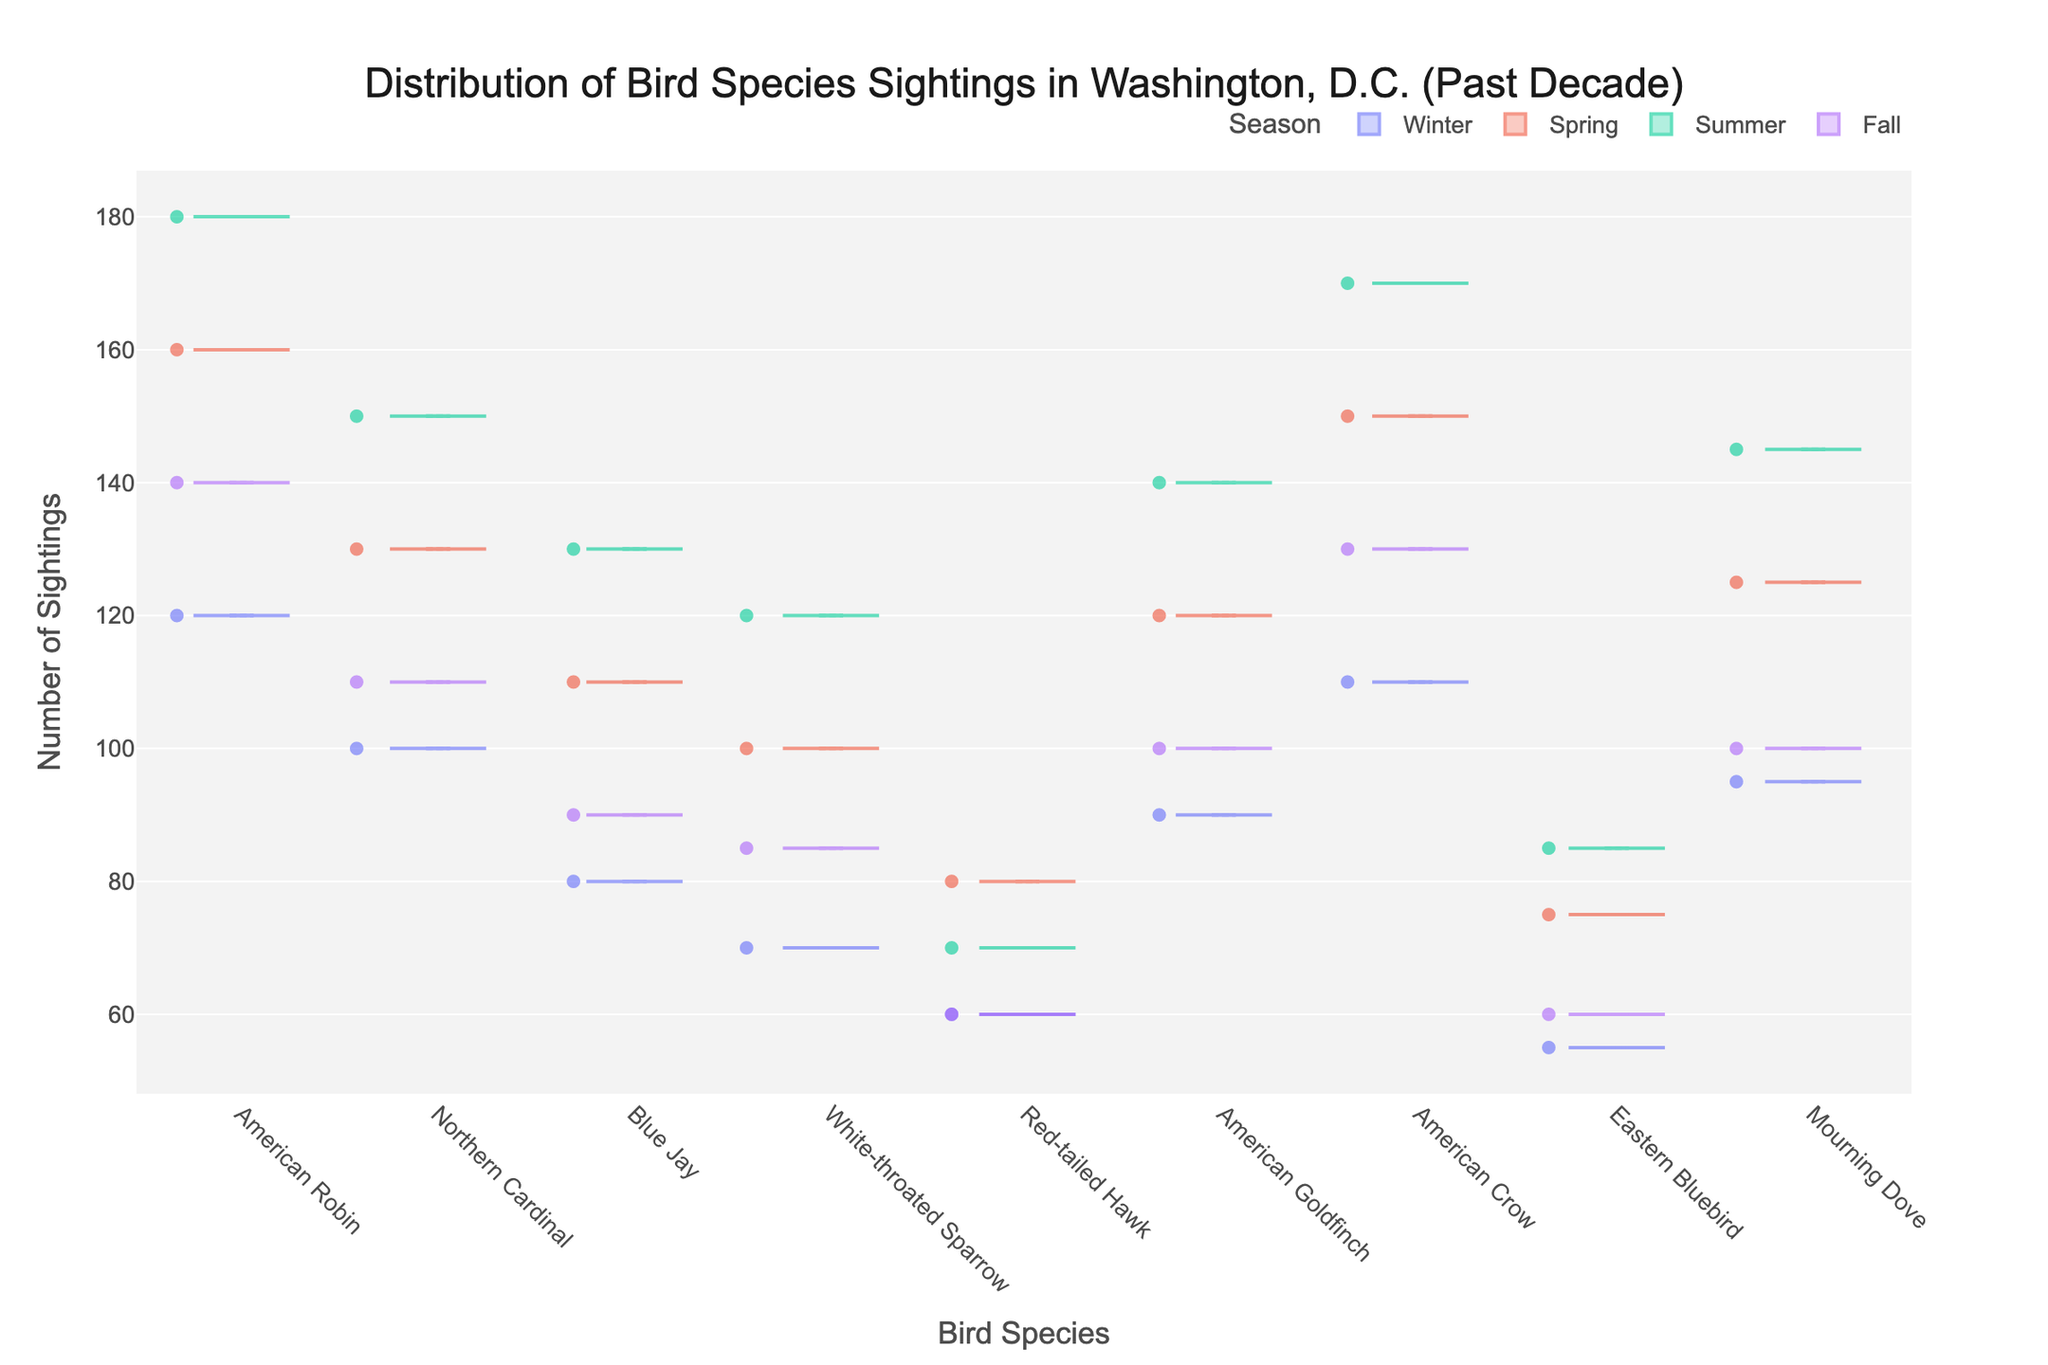Which season has the highest sightings of the American Robin? By looking at the violin plots of all four seasons for American Robin, the Summer plot shows the highest median value, indicating the highest sightings.
Answer: Summer What is the average number of sightings for the Northern Cardinal in Spring and Fall? The sightings for Northern Cardinal in Spring and Fall are 130 and 110 respectively. The average can be calculated as (130 + 110) / 2 = 120.
Answer: 120 Which bird species has the lowest number of sightings in Winter? By comparing the winter violin plots for all bird species, the Eastern Bluebird has the lowest median value.
Answer: Eastern Bluebird Are there any seasons where the number of sightings for Red-tailed Hawk remains constant? Observing the violin plots for Red-tailed Hawk, its distribution shows a similar range in Winter and Fall, indicating a constant number of sightings.
Answer: Winter and Fall What is the range of sightings for the American Goldfinch in Summer? By examining the Summer violin plot for American Goldfinch, the range can be seen between the minimum and maximum whisker points of the plot.
Answer: 140 to 140 How do the sightings of the American Crow compare between Summer and Winter? Observing the violin plots, the Summer sightings of American Crow are higher as indicated by both median and density compared to Winter.
Answer: Higher in Summer Which bird species has the most consistent number of sightings across all seasons? By comparing the ranges and medians in the violin plots, the Red-tailed Hawk has the most consistent number of sightings with a relatively narrow distribution.
Answer: Red-tailed Hawk What is the difference in the number of sightings of the Mourning Dove between Spring and Summer? By comparing the violin plots, the Spring sightings are 125, and Summer sightings are 145. The difference is 145 - 125 = 20.
Answer: 20 Which season shows the greatest variability in bird sightings for the White-throated Sparrow? By examining the spread of the violin plots, the Summer season shows the widest spread for White-throated Sparrow, indicating the greatest variability.
Answer: Summer 